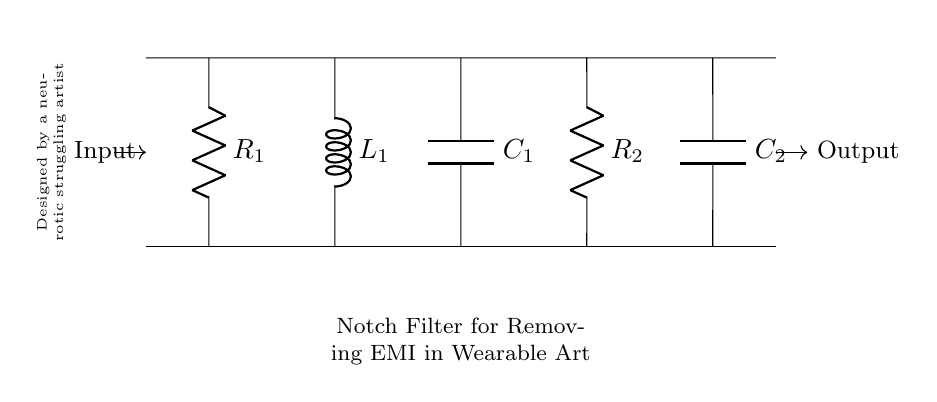What type of filter is depicted in this circuit? The circuit diagram clearly labels itself as a "Notch Filter," which is specifically designed to remove unwanted frequencies from a signal. The name itself indicates the filter type.
Answer: Notch Filter What are the two reactive components present in the circuit? The circuit includes an inductor denoted as L1 and two capacitors labeled C1 and C2. These components are responsible for creating the filter's frequency response.
Answer: Inductor and Capacitors How many resistors are shown in the circuit? The diagram indicates there are two resistors labeled R1 and R2. By counting the resistor symbols in the circuit, we determine there are two present.
Answer: Two Which component influences the low-frequency response of the notch filter? The capacitor C1 plays a crucial role in shaping the low-frequency response of the circuit, as capacitors block DC and typically influence the lower frequencies of the signal.
Answer: Capacitor C1 What role does the inductor play in this circuit? The inductor L1 helps to block high-frequency signals while allowing lower frequencies to pass through, contributing to the filter’s notch characteristics by creating a frequency-dependent response.
Answer: Blocks high frequencies What is the main purpose of this circuit? The circuit's primary objective is to remove unwanted electromagnetic interference, as specified in the title. This is aimed at enhancing the signal quality for wearable art pieces.
Answer: Remove electromagnetic interference At which ends are the input and output of the circuit located? The input is located on the left side of the circuit, where the line points towards the circuit, and the output is on the right side, extending from the last component to a designated output point.
Answer: Left for input, right for output 